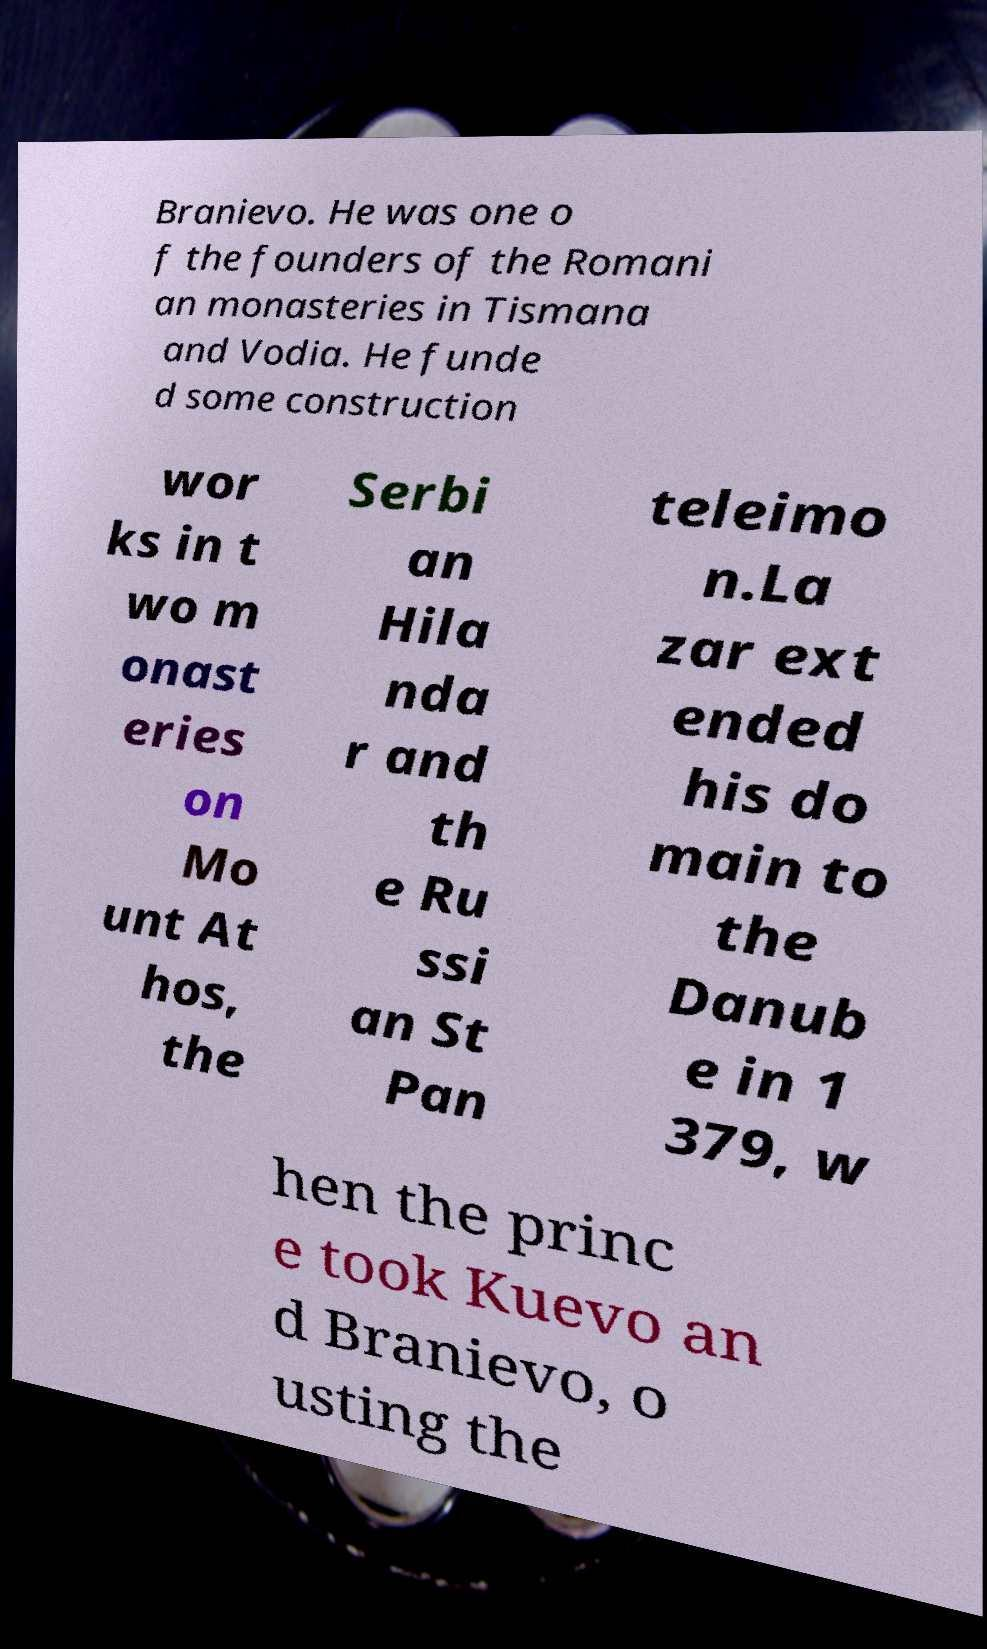Please read and relay the text visible in this image. What does it say? Branievo. He was one o f the founders of the Romani an monasteries in Tismana and Vodia. He funde d some construction wor ks in t wo m onast eries on Mo unt At hos, the Serbi an Hila nda r and th e Ru ssi an St Pan teleimo n.La zar ext ended his do main to the Danub e in 1 379, w hen the princ e took Kuevo an d Branievo, o usting the 